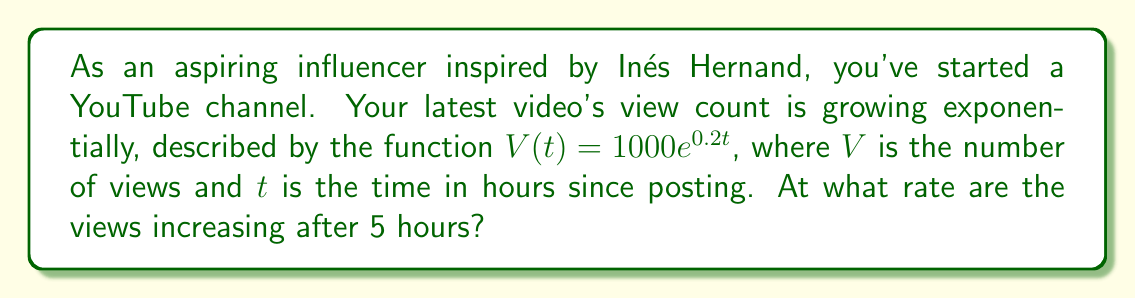Provide a solution to this math problem. To find the rate at which views are increasing after 5 hours, we need to calculate the derivative of the given function and evaluate it at $t=5$. Here's the step-by-step process:

1) The given function is $V(t) = 1000e^{0.2t}$

2) To find the rate of change, we need to differentiate $V(t)$ with respect to $t$:
   $$\frac{dV}{dt} = 1000 \cdot 0.2e^{0.2t} = 200e^{0.2t}$$

3) This derivative represents the instantaneous rate of change of views with respect to time.

4) To find the rate after 5 hours, we substitute $t=5$ into the derivative:
   $$\frac{dV}{dt}\bigg|_{t=5} = 200e^{0.2(5)} = 200e^1 \approx 543.56$$

5) Therefore, after 5 hours, the views are increasing at a rate of approximately 543.56 views per hour.
Answer: 543.56 views/hour 